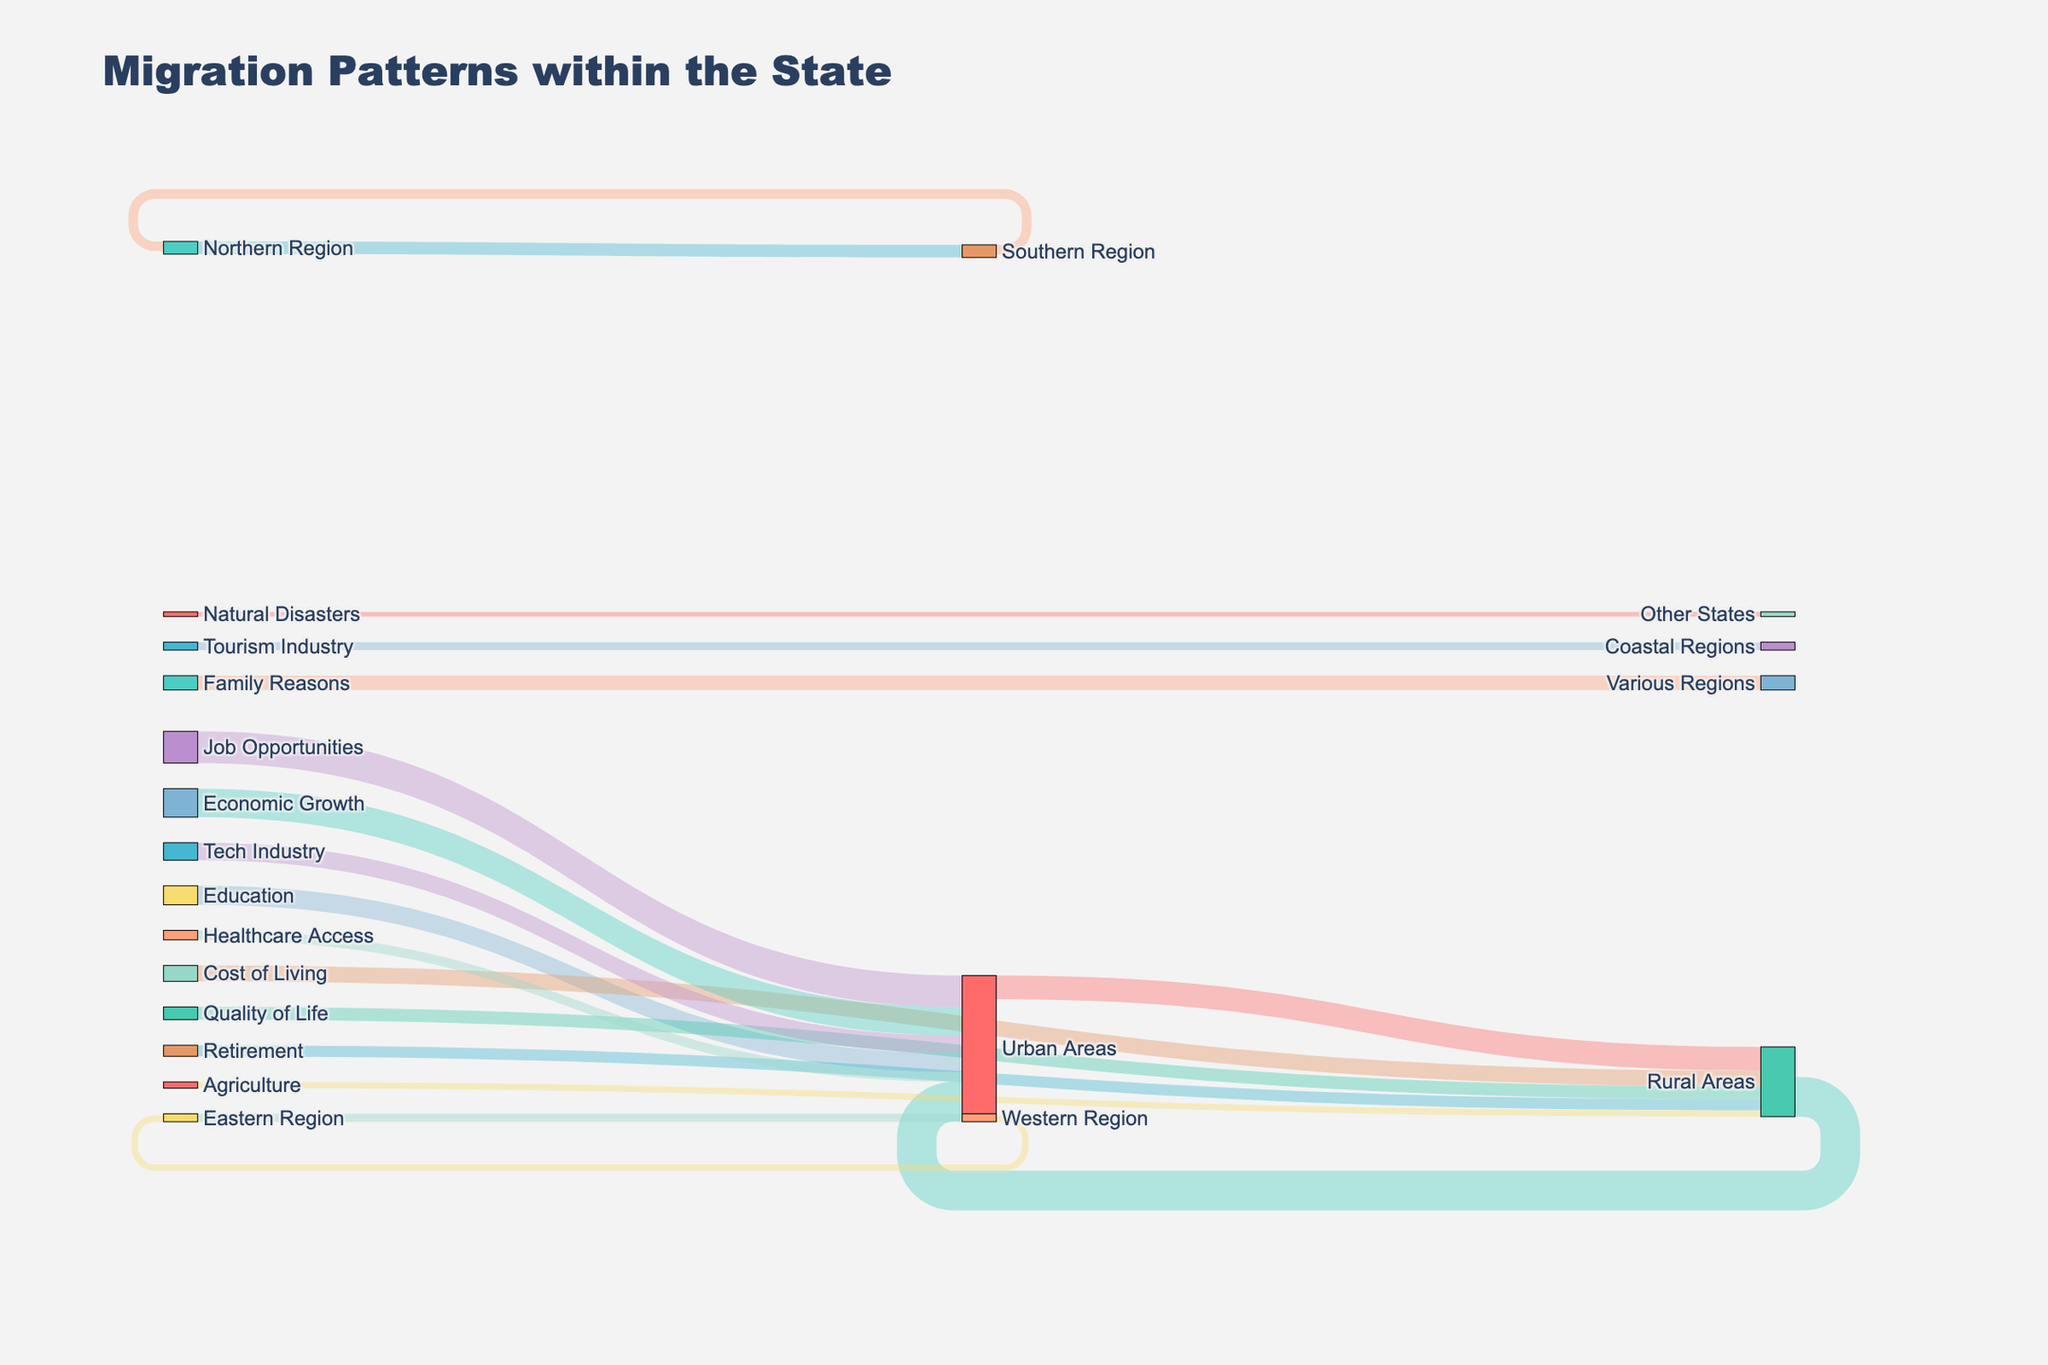What's the total number of people moving from rural areas to all other regions? Total migration from rural areas can be calculated by adding the value of people moving to urban areas from rural areas (25,000) and those moving to other regions not directly specified (0). This results in 25,000 people.
Answer: 25,000 Which migration flow has the highest value? The migration flow with the highest value can be identified by visually comparing the lengths and thicknesses of the link lines in the Sankey diagram. The longest and thickest link line represents "Job Opportunities" to "Urban Areas" with a value of 20,000.
Answer: Job Opportunities to Urban Areas Is the migration from Urban Areas to Rural Areas greater than the migration from Rural Areas to Urban Areas? To compare these values, look for the corresponding link lines in the Sankey diagram. The value for migration from Urban Areas to Rural Areas is 15,000, while from Rural Areas to Urban Areas it is 25,000. Therefore, migration from Rural Areas to Urban Areas is greater.
Answer: No How many people migrate from the Southern Region to the Northern Region? Observe the link line starting from the Southern Region and ending at the Northern Region in the Sankey diagram. The specified flow is represented by a value of 6,000.
Answer: 6,000 What is the primary reason for people moving to Urban Areas? The primary reason can be identified by finding the greatest inflow into Urban Areas. "Job Opportunities" has the highest value of 20,000, followed by other reasons. Hence, job opportunities are the primary reason.
Answer: Job Opportunities Are more people moving from the Northern Region to the Southern Region or vice versa? Examine the values for both migration flows depicted in the Sankey diagram. The value for moving from the Northern Region to the Southern Region is 8,000, whereas from the Southern Region to the Northern Region it is 6,000.
Answer: Northern Region to Southern Region How many people are moving to Rural Areas because of Cost of Living and Quality of Life combined? To get the combined value, sum the values of Cost of Living (10,000) and Quality of Life (8,000) migrations directed towards Rural Areas. 10,000 + 8,000 = 18,000.
Answer: 18,000 Which region has the smallest migration outflow to another specific region? Find the smallest numerical value representing migration outflow among regions specified in the Sankey diagram. The smallest outflow is from the Western Region to the Eastern Region with a value of 4,000.
Answer: Western Region to Eastern Region What industry-related reason attracts the most people to Urban Areas? Look for the industry-related reasons linked to Urban Areas. Comparing values, the "Tech Industry" attracts more (11,000) than any other listed industry-related reason.
Answer: Tech Industry 